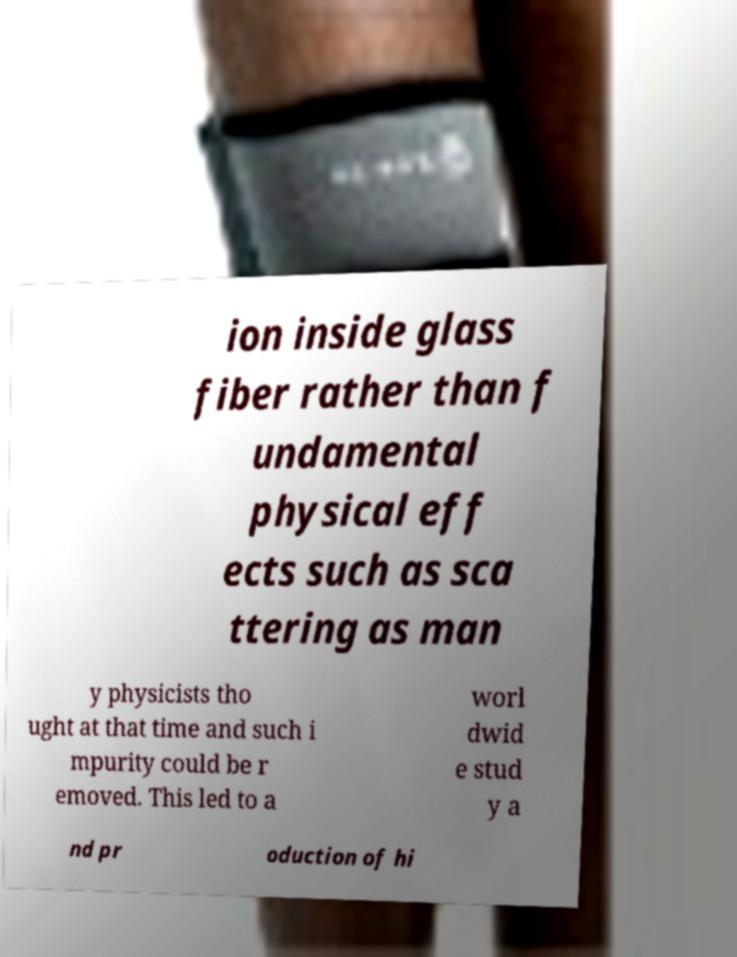Could you extract and type out the text from this image? ion inside glass fiber rather than f undamental physical eff ects such as sca ttering as man y physicists tho ught at that time and such i mpurity could be r emoved. This led to a worl dwid e stud y a nd pr oduction of hi 